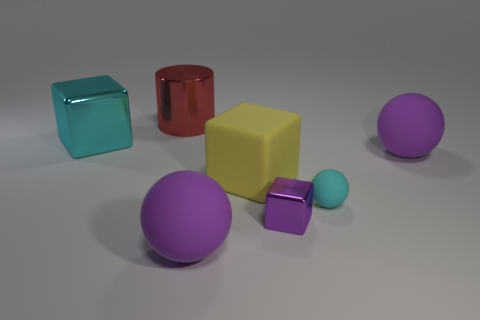Are there more yellow matte blocks that are in front of the small cyan rubber thing than purple balls?
Ensure brevity in your answer.  No. Is there a small purple object?
Your answer should be very brief. Yes. How many cyan objects are the same size as the purple metal block?
Ensure brevity in your answer.  1. Are there more cylinders that are behind the cylinder than purple cubes behind the large yellow rubber thing?
Provide a short and direct response. No. There is a cyan cube that is the same size as the red metal thing; what material is it?
Your answer should be very brief. Metal. The cyan metallic thing is what shape?
Offer a very short reply. Cube. What number of cyan things are either big shiny cylinders or small things?
Keep it short and to the point. 1. What size is the cyan sphere that is the same material as the yellow cube?
Make the answer very short. Small. Is the material of the cyan object that is to the left of the small cyan rubber ball the same as the purple object left of the purple metallic cube?
Your response must be concise. No. How many blocks are red metal objects or large objects?
Your answer should be compact. 2. 